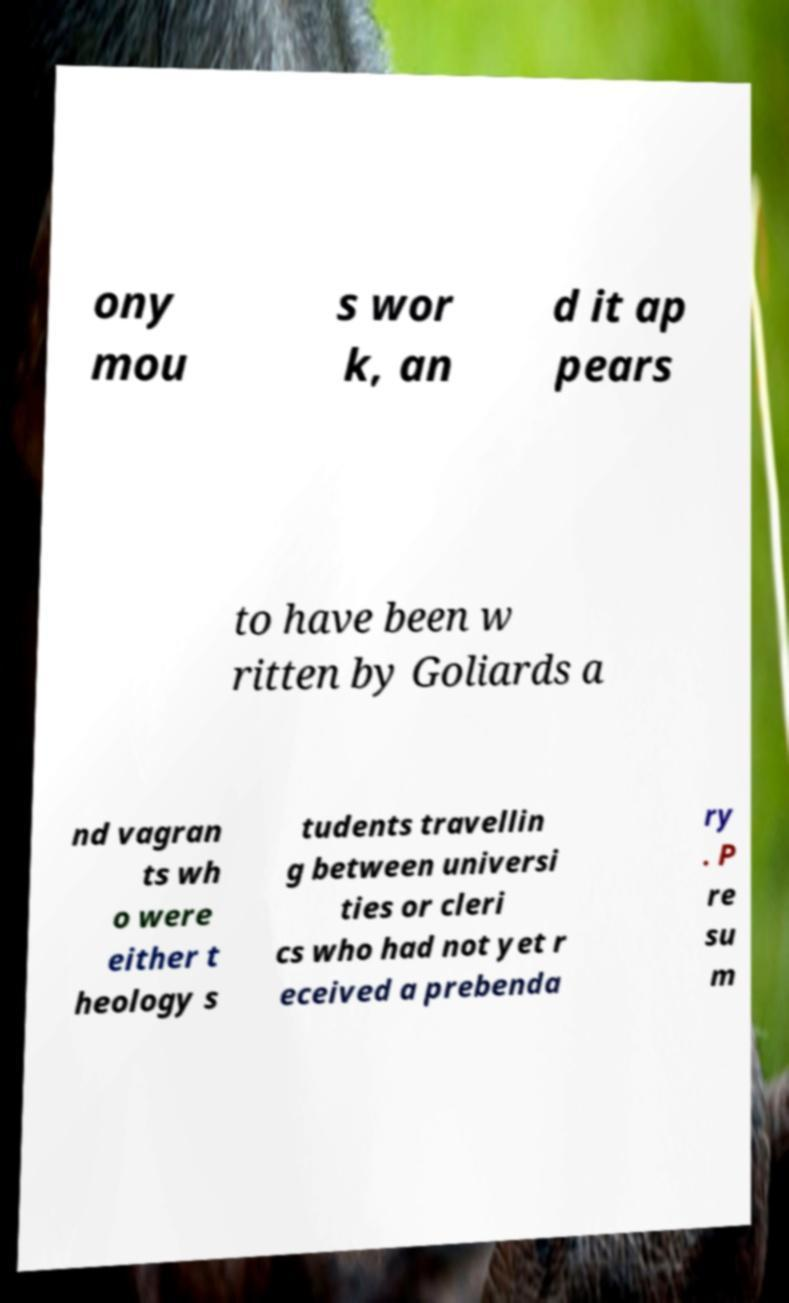I need the written content from this picture converted into text. Can you do that? ony mou s wor k, an d it ap pears to have been w ritten by Goliards a nd vagran ts wh o were either t heology s tudents travellin g between universi ties or cleri cs who had not yet r eceived a prebenda ry . P re su m 